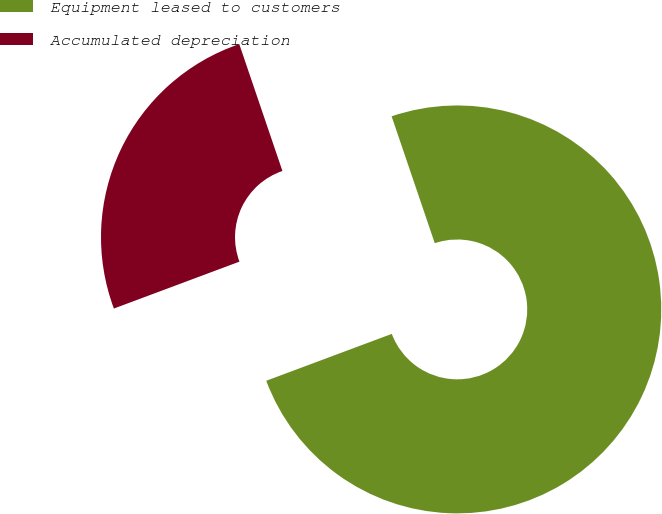Convert chart. <chart><loc_0><loc_0><loc_500><loc_500><pie_chart><fcel>Equipment leased to customers<fcel>Accumulated depreciation<nl><fcel>74.53%<fcel>25.47%<nl></chart> 